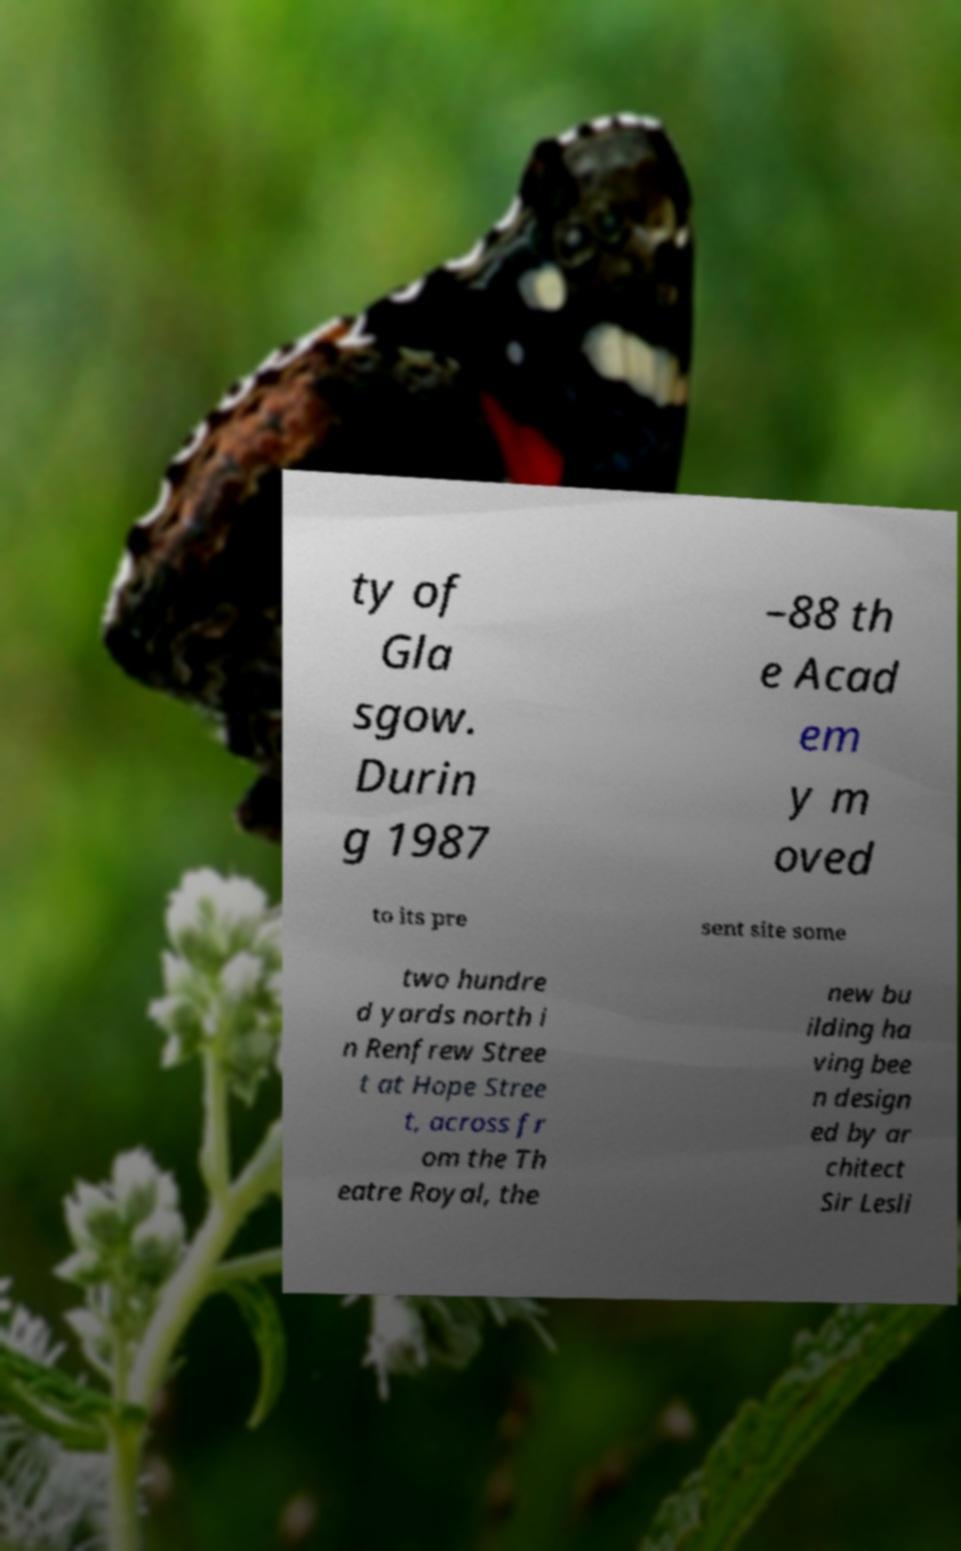Can you read and provide the text displayed in the image?This photo seems to have some interesting text. Can you extract and type it out for me? ty of Gla sgow. Durin g 1987 –88 th e Acad em y m oved to its pre sent site some two hundre d yards north i n Renfrew Stree t at Hope Stree t, across fr om the Th eatre Royal, the new bu ilding ha ving bee n design ed by ar chitect Sir Lesli 